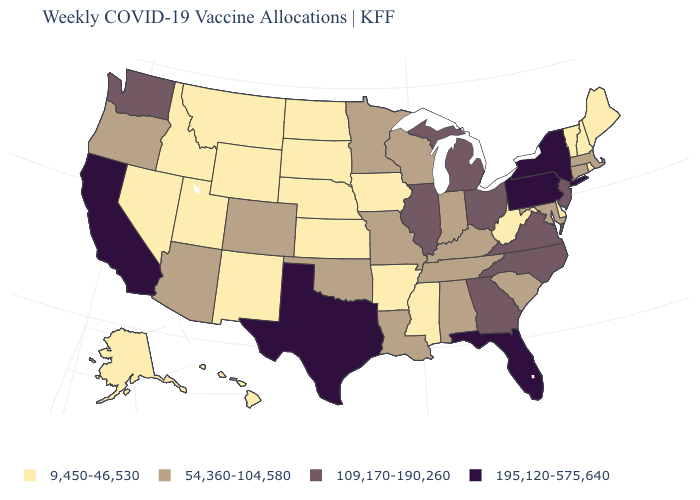What is the highest value in states that border Maryland?
Keep it brief. 195,120-575,640. What is the value of Idaho?
Keep it brief. 9,450-46,530. Does Idaho have the lowest value in the USA?
Keep it brief. Yes. Name the states that have a value in the range 9,450-46,530?
Keep it brief. Alaska, Arkansas, Delaware, Hawaii, Idaho, Iowa, Kansas, Maine, Mississippi, Montana, Nebraska, Nevada, New Hampshire, New Mexico, North Dakota, Rhode Island, South Dakota, Utah, Vermont, West Virginia, Wyoming. Name the states that have a value in the range 195,120-575,640?
Quick response, please. California, Florida, New York, Pennsylvania, Texas. Does Oklahoma have a higher value than Tennessee?
Short answer required. No. Does Colorado have the lowest value in the USA?
Give a very brief answer. No. Name the states that have a value in the range 9,450-46,530?
Short answer required. Alaska, Arkansas, Delaware, Hawaii, Idaho, Iowa, Kansas, Maine, Mississippi, Montana, Nebraska, Nevada, New Hampshire, New Mexico, North Dakota, Rhode Island, South Dakota, Utah, Vermont, West Virginia, Wyoming. Does Delaware have the same value as Washington?
Write a very short answer. No. What is the lowest value in the USA?
Concise answer only. 9,450-46,530. What is the value of Georgia?
Be succinct. 109,170-190,260. Does Colorado have a lower value than Massachusetts?
Give a very brief answer. No. What is the value of Kansas?
Concise answer only. 9,450-46,530. Which states have the lowest value in the USA?
Short answer required. Alaska, Arkansas, Delaware, Hawaii, Idaho, Iowa, Kansas, Maine, Mississippi, Montana, Nebraska, Nevada, New Hampshire, New Mexico, North Dakota, Rhode Island, South Dakota, Utah, Vermont, West Virginia, Wyoming. What is the value of Montana?
Quick response, please. 9,450-46,530. 